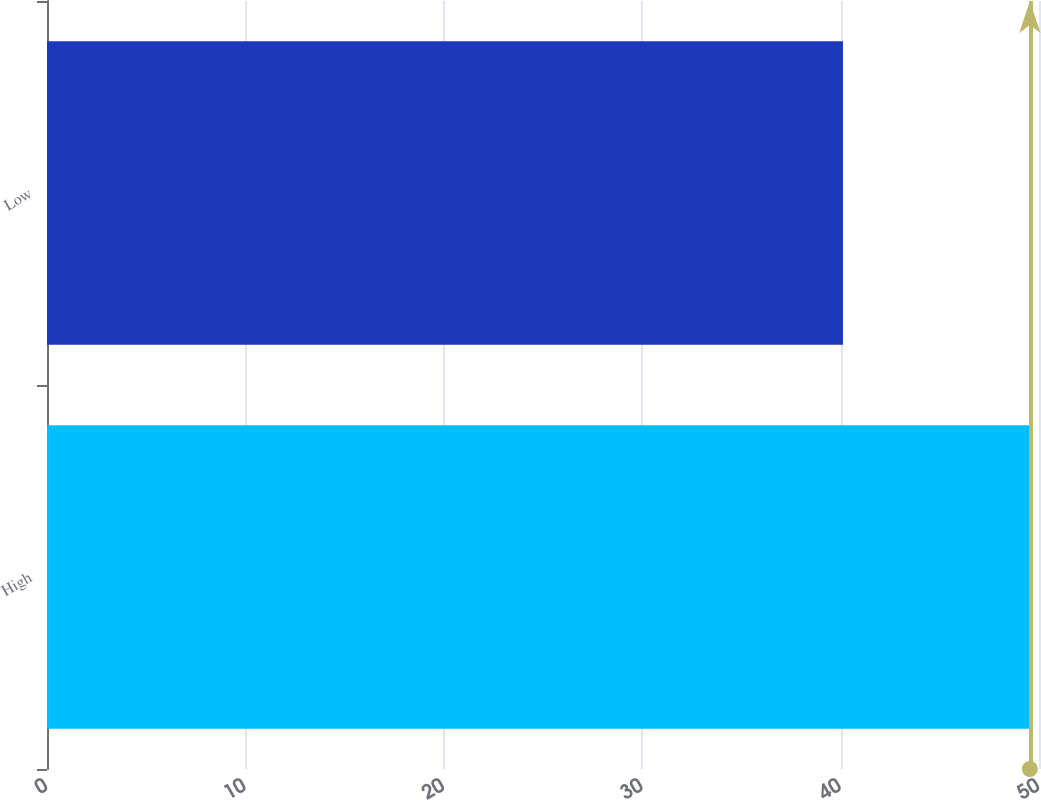Convert chart. <chart><loc_0><loc_0><loc_500><loc_500><bar_chart><fcel>High<fcel>Low<nl><fcel>49.54<fcel>40.12<nl></chart> 